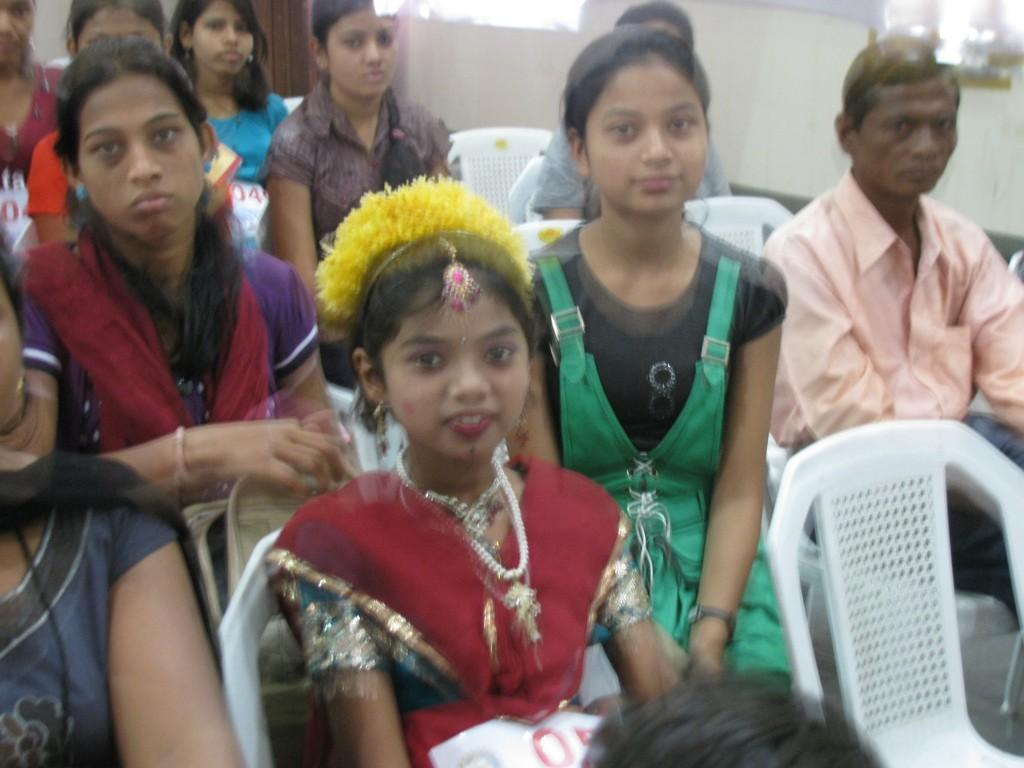What are the children doing in the image? The children are sitting on chairs in the image. Can you describe the person sitting on a chair in the image? There is a person sitting on a chair on the right side of the image. What can be seen at the top of the image? There is a wall visible at the top of the image. What type of tax is being discussed by the children in the image? There is no indication in the image that the children are discussing any type of tax. 